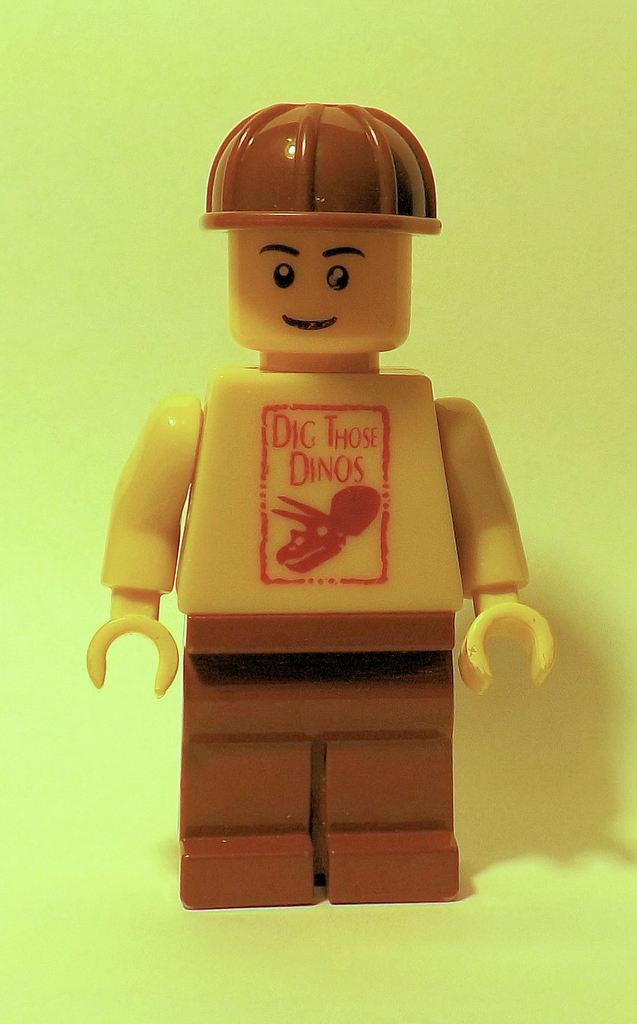What object can be seen in the image? There is a toy in the image. What color is the background of the image? The background of the image is light green. What type of tree is hanging from the string in the image? There is no tree or string present in the image; it only features a toy and a light green background. 